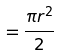<formula> <loc_0><loc_0><loc_500><loc_500>= \frac { \pi r ^ { 2 } } { 2 }</formula> 